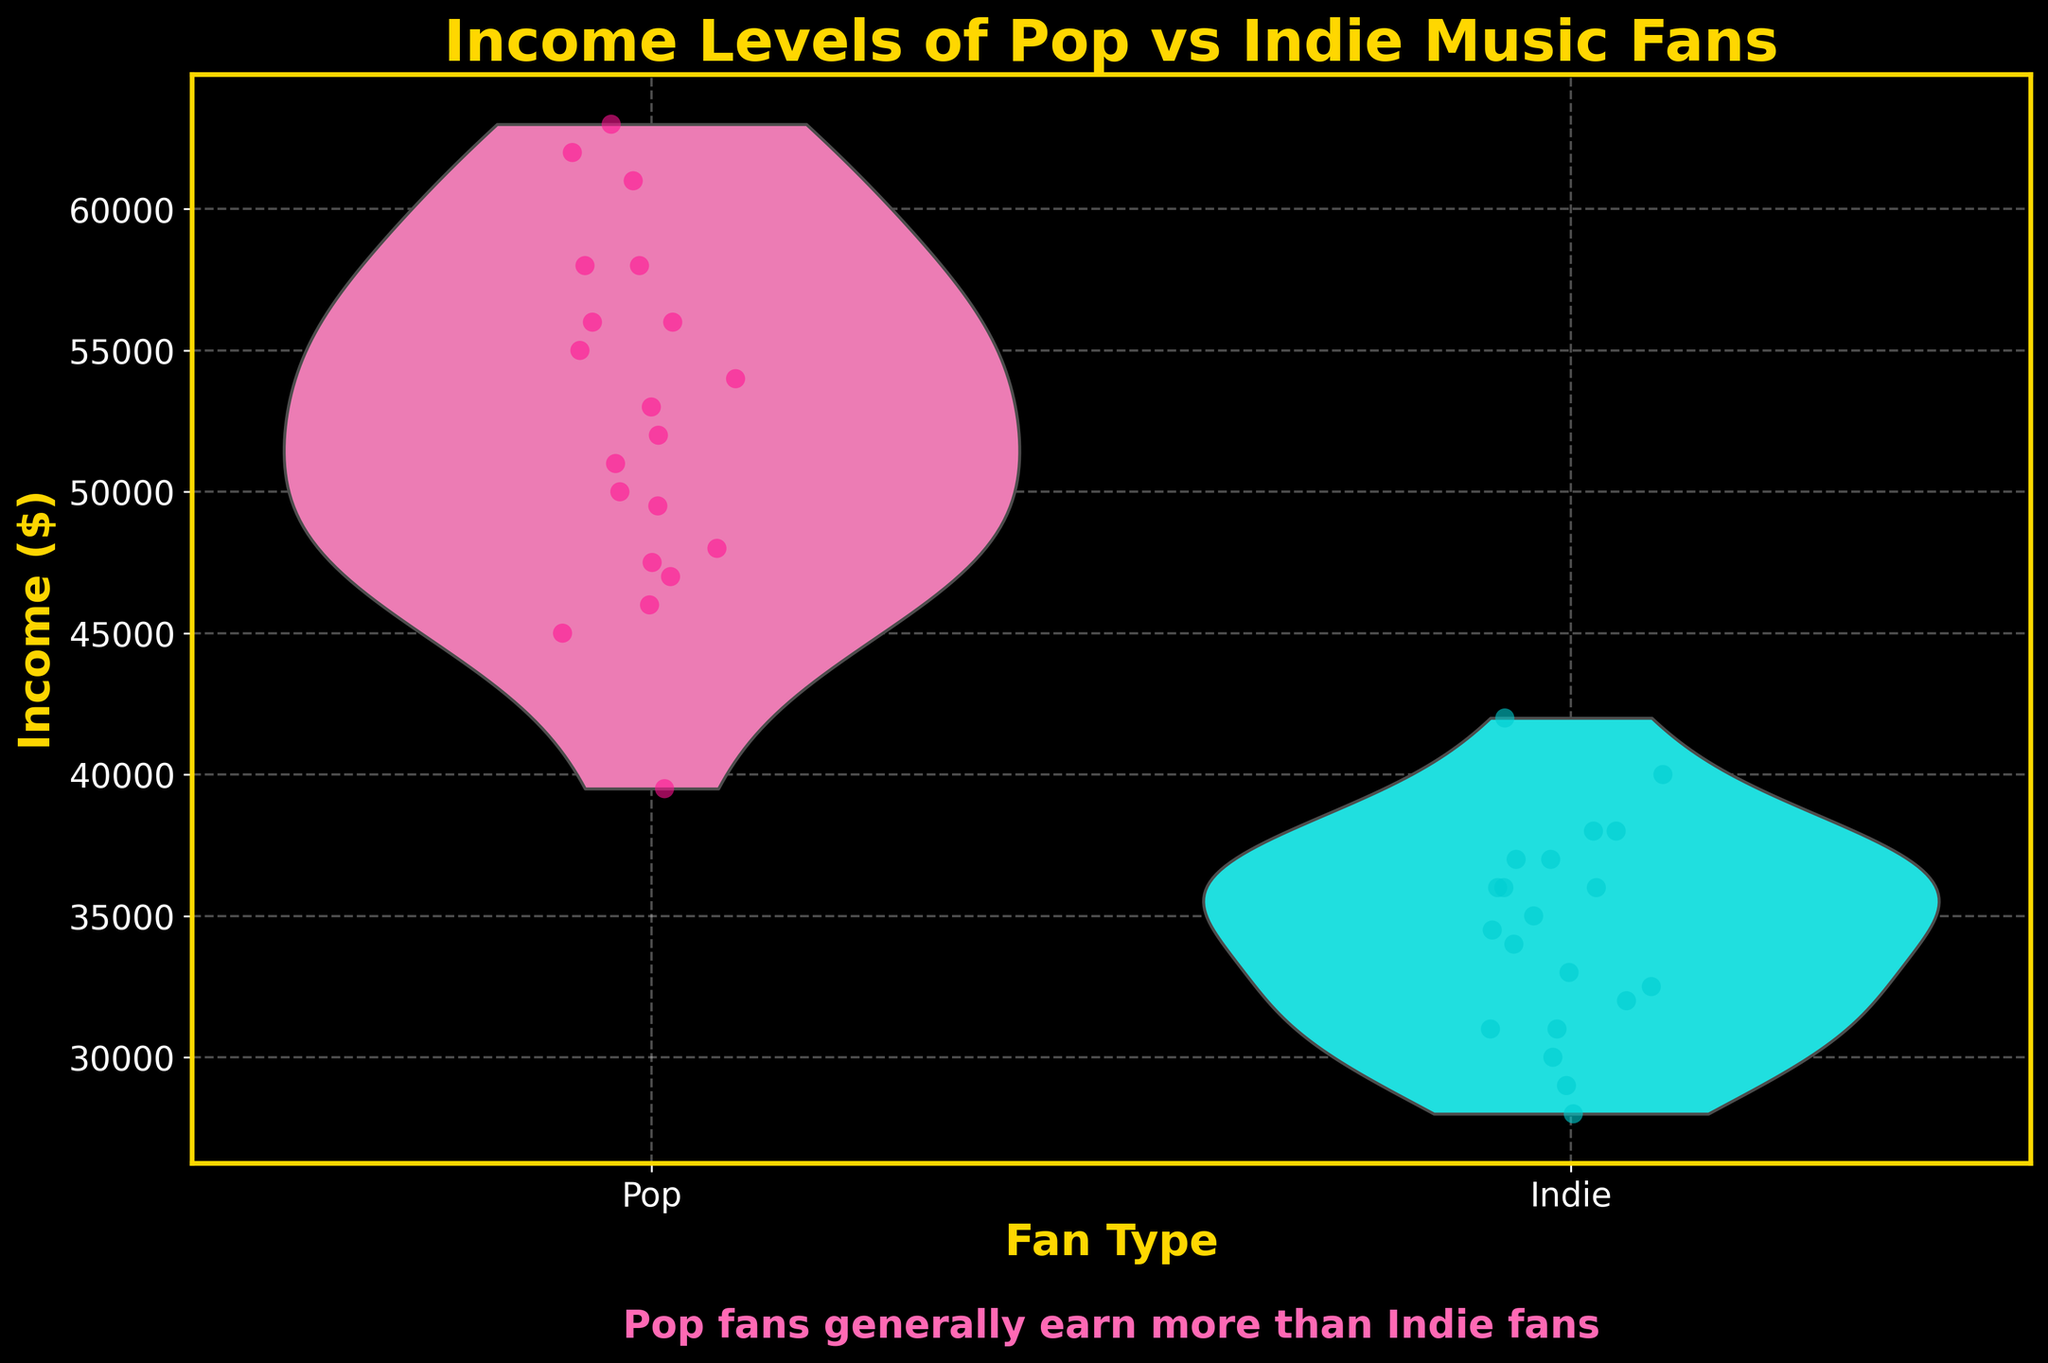What is the title of the chart? The title of the chart is located at the top, indicating the overall subject of the visualization, which is the income levels of pop and indie music fans.
Answer: Income Levels of Pop vs Indie Music Fans What are the labels for the x-axis and y-axis? The x-axis label shows the types of music fans, while the y-axis label displays the income levels in dollars.
Answer: Fan Type and Income ($) What are the colors used for the Pop and Indie fan groups? The colors used in the chart distinguish between Pop and Indie fan groups. Pop fans are represented with pink shades (#FF69B4 and #FF1493), while Indie fans are shown in cyan shades (#00FFFF and #00CED1).
Answer: Pink for Pop and Cyan for Indie Which group has the highest recorded income? To determine the highest recorded income, observe the jittered points or the overall distribution in the violins. The maximum jittered point for Pop fans is at $63,000, which is higher than all points of Indie fans.
Answer: Pop fans What is the median income of Pop fans? The median income is found by looking at the central white dot on the violin plot for Pop fans. This dot represents the median value around the $52,500 mark.
Answer: $52,000 What is the range of income levels for Indie music fans? The range can be determined by observing the highest and lowest jittered points for Indie fans. The highest is $42,000, and the lowest is $28,000. Thus, the range is $42,000 - $28,000 = $14,000.
Answer: $14,000 Compare the shapes of the violin plots for Pop and Indie fans. What can you infer about the income distributions? The violin plot for Pop fans is wider in the middle and tapers at higher and lower ends, indicating a higher concentration of data points around the median. In contrast, the Indie violin plot is narrower and more uniformly shaped, showing a less concentrated distribution. These shapes suggest Pop fans have a more clustered income level around the median, while Indie fans have a more evenly spread income range.
Answer: Pop fans have a more concentrated median, Indie fans have a more spread income distribution Is there any overlap in the income distributions between Pop and Indie fans? To see overlap, observe where the violin plots intersect. Both distributions overlap between approximately $39,500 and $42,000, meaning some individuals from both groups have incomes within this range.
Answer: Yes, between $39,500 and $42,000 What is the average income of Pop fans? The average income can be calculated by summing all Pop fans' incomes and dividing by the total number of Pop data points. Summing the incomes (45000 + 55000 + 47000 + … + 58000) and then dividing by 20, the average income is (1,015,500 / 20) = $50,775.
Answer: $50,775 Which group has a wider spread of income levels? Observing the overall length of each violin plot, Pop fans have a wider range from about $39,500 to $63,000, over $23,500. Indie fans span from $28,000 to $42,000, a range of $14,000. Hence, Pop fans have a wider spread.
Answer: Pop fans 